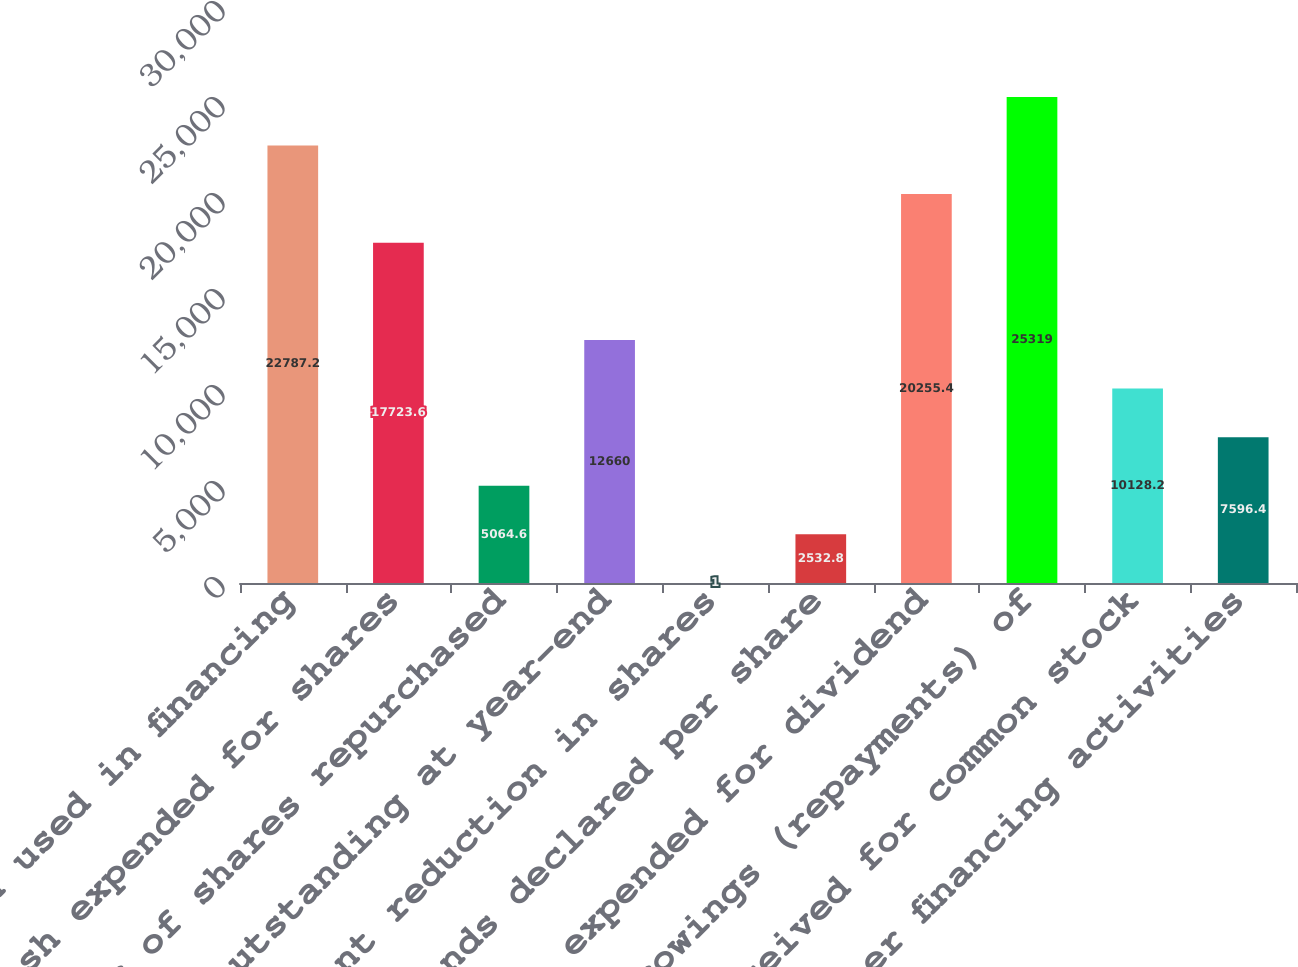Convert chart to OTSL. <chart><loc_0><loc_0><loc_500><loc_500><bar_chart><fcel>Net cash used in financing<fcel>Cash expended for shares<fcel>Number of shares repurchased<fcel>Shares outstanding at year-end<fcel>Percent reduction in shares<fcel>Dividends declared per share<fcel>Cash expended for dividend<fcel>Net borrowings (repayments) of<fcel>Cash received for common stock<fcel>Other financing activities<nl><fcel>22787.2<fcel>17723.6<fcel>5064.6<fcel>12660<fcel>1<fcel>2532.8<fcel>20255.4<fcel>25319<fcel>10128.2<fcel>7596.4<nl></chart> 